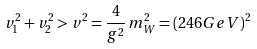Convert formula to latex. <formula><loc_0><loc_0><loc_500><loc_500>v _ { 1 } ^ { 2 } + v _ { 2 } ^ { 2 } > v ^ { 2 } = \frac { 4 } { g ^ { 2 } } \, m _ { W } ^ { 2 } = ( 2 4 6 G e V ) ^ { 2 }</formula> 